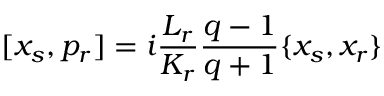Convert formula to latex. <formula><loc_0><loc_0><loc_500><loc_500>[ x _ { s } , p _ { r } ] = i \frac { L _ { r } } { K _ { r } } \frac { q - 1 } { q + 1 } \{ x _ { s } , x _ { r } \}</formula> 